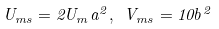Convert formula to latex. <formula><loc_0><loc_0><loc_500><loc_500>U _ { m s } = 2 U _ { m } a ^ { 2 } , \text { } V _ { m s } = 1 0 b ^ { 2 }</formula> 